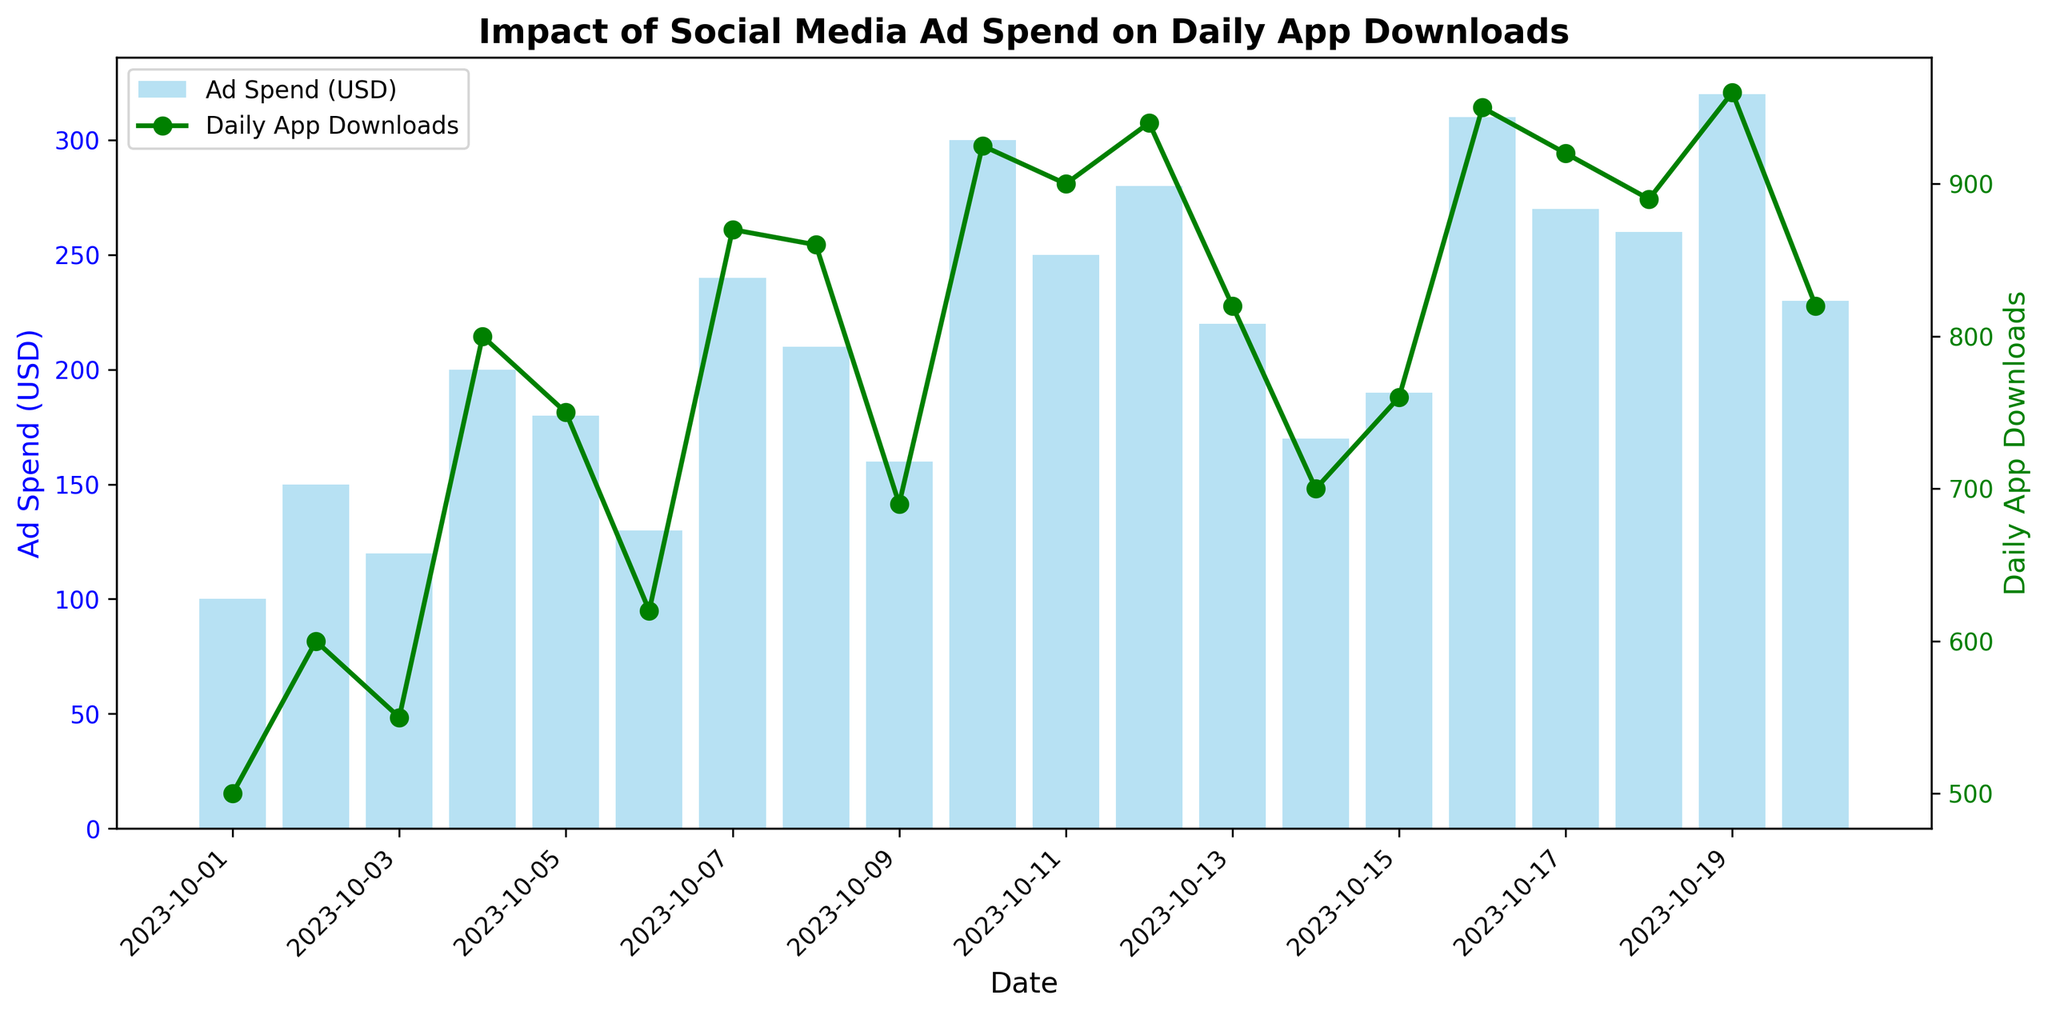What is the highest ad spend shown in the figure? To determine the highest ad spend, look for the tallest bar in the figure that represents ad spend in USD. The tallest bar is labeled with a value of 320 USD on 2023-10-19.
Answer: 320 USD How does the app download trend on 2023-10-10 compare to the days right before and after it? On 2023-10-10, the app downloads are 925, which shows an increase compared to the downloads on 2023-10-09 (690 downloads) and a slight increase over 2023-10-11 (900 downloads).
Answer: Increased before and slightly increased after What day had the lowest app downloads, and what was the ad spend on that day? By examining the line plot for daily app downloads, the lowest point is on 2023-10-01 with 500 downloads, and the ad spend on that day, represented by the corresponding bar, is 100 USD.
Answer: 2023-10-01, 100 USD What is the average ad spend over the displayed period? To calculate the average ad spend, sum all the ad spend values and divide by the number of days. Total ad spend is 100 + 150 + 120 + 200 + 180 + 130 + 240 + 210 + 160 + 300 + 250 + 280 + 220 + 170 + 190 + 310 + 270 + 260 + 320 + 230 = 4500 USD. There are 20 days, so the average ad spend is 4500 / 20 = 225 USD.
Answer: 225 USD How do ad spends and app downloads on 2023-10-06 and 2023-10-07 compare? On 2023-10-06, the ad spend was 130 USD with 620 app downloads. On 2023-10-07, the ad spend increased to 240 USD with 870 app downloads. The ad spend and downloads both increased from 2023-10-06 to 2023-10-07.
Answer: Both increased Between 2023-10-14 and 2023-10-15, which day had higher app downloads, and by how much? On 2023-10-14, there were 700 app downloads, while on 2023-10-15, there were 760 app downloads. The difference in downloads between the two days is 760 - 700 = 60 downloads.
Answer: 2023-10-15 by 60 downloads Do higher ad spends consistently result in increased app downloads based on the given data? While there is a general trend where higher ad spends often correlate with more app downloads, it is not consistent. For example, on 2023-10-10, ad spend was 300 USD with 925 downloads, while on 2023-10-16, ad spend was 310 USD with 950 downloads, which is a lower increase in downloads relative to the increase in spend.
Answer: Not consistent Which day had the sharpest increase in app downloads compared to the previous day, and what were the values? The sharpest increase can be found by comparing daily downloads. Between 2023-10-09 and 2023-10-10, downloads increase from 690 to 925, an increase of 235 downloads, which is the highest observed increment.
Answer: 2023-10-10, 235 downloads What is the total number of app downloads over the entire period? Sum all the values for daily app downloads. The total is 500 + 600 + 550 + 800 + 750 + 620 + 870 + 860 + 690 + 925 + 900 + 940 + 820 + 700 + 760 + 950 + 920 + 890 + 960 + 820 = 17225 downloads.
Answer: 17225 downloads 